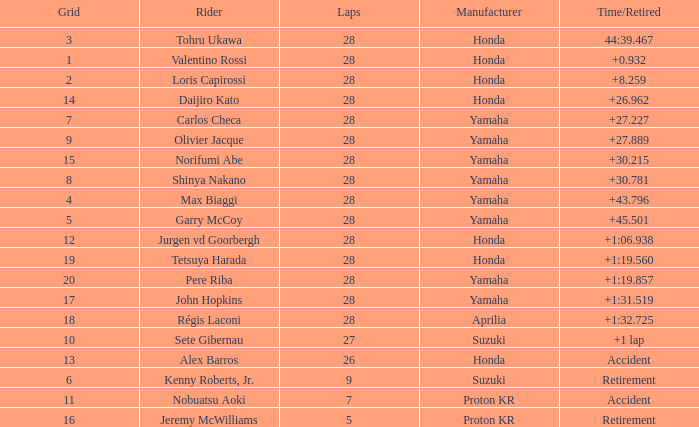Who manufactured grid 11? Proton KR. 